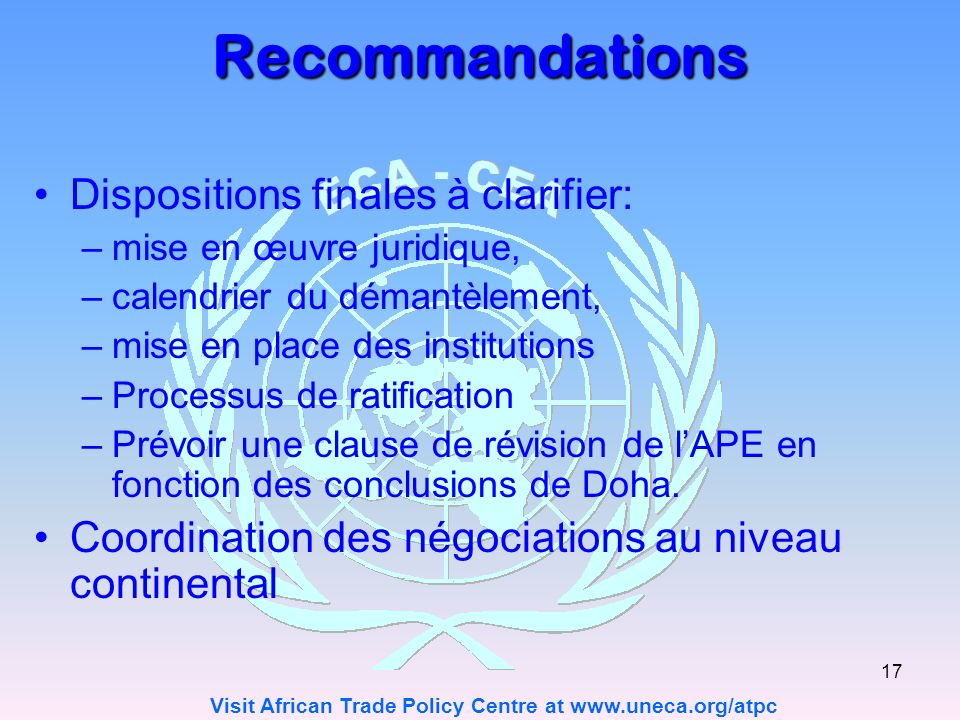What might be the implications of the recommended clause for revising the APE based on the Doha conclusions? The implications of incorporating a revision clause into the APE as recommended, based on the conclusions from the Doha round, could be substantial and multidimensional. Firstly, introducing such a clause could enforce legal frameworks that ensure that any new decisions or policies from the Doha discussions are integrated into the APE swiftly and effectively. This could include updating trade regulations and compliance standards to align with the latest international trade agreements which could result in a more dynamic and adaptive economic partnership. Additionally, this clause could mandate the establishment of schedules for dismantling tariffs or barriers consistent with the agreed conclusions in Doha, potentially making trade more fluid and reducing costs. Finally, it sets a precedence for the ratification process, involving more rigorous assessments and adjustments to policies, which may help in tailoring the APE to be more responsive to the changes in the global economic climate prompted by the Doha outcomes. 